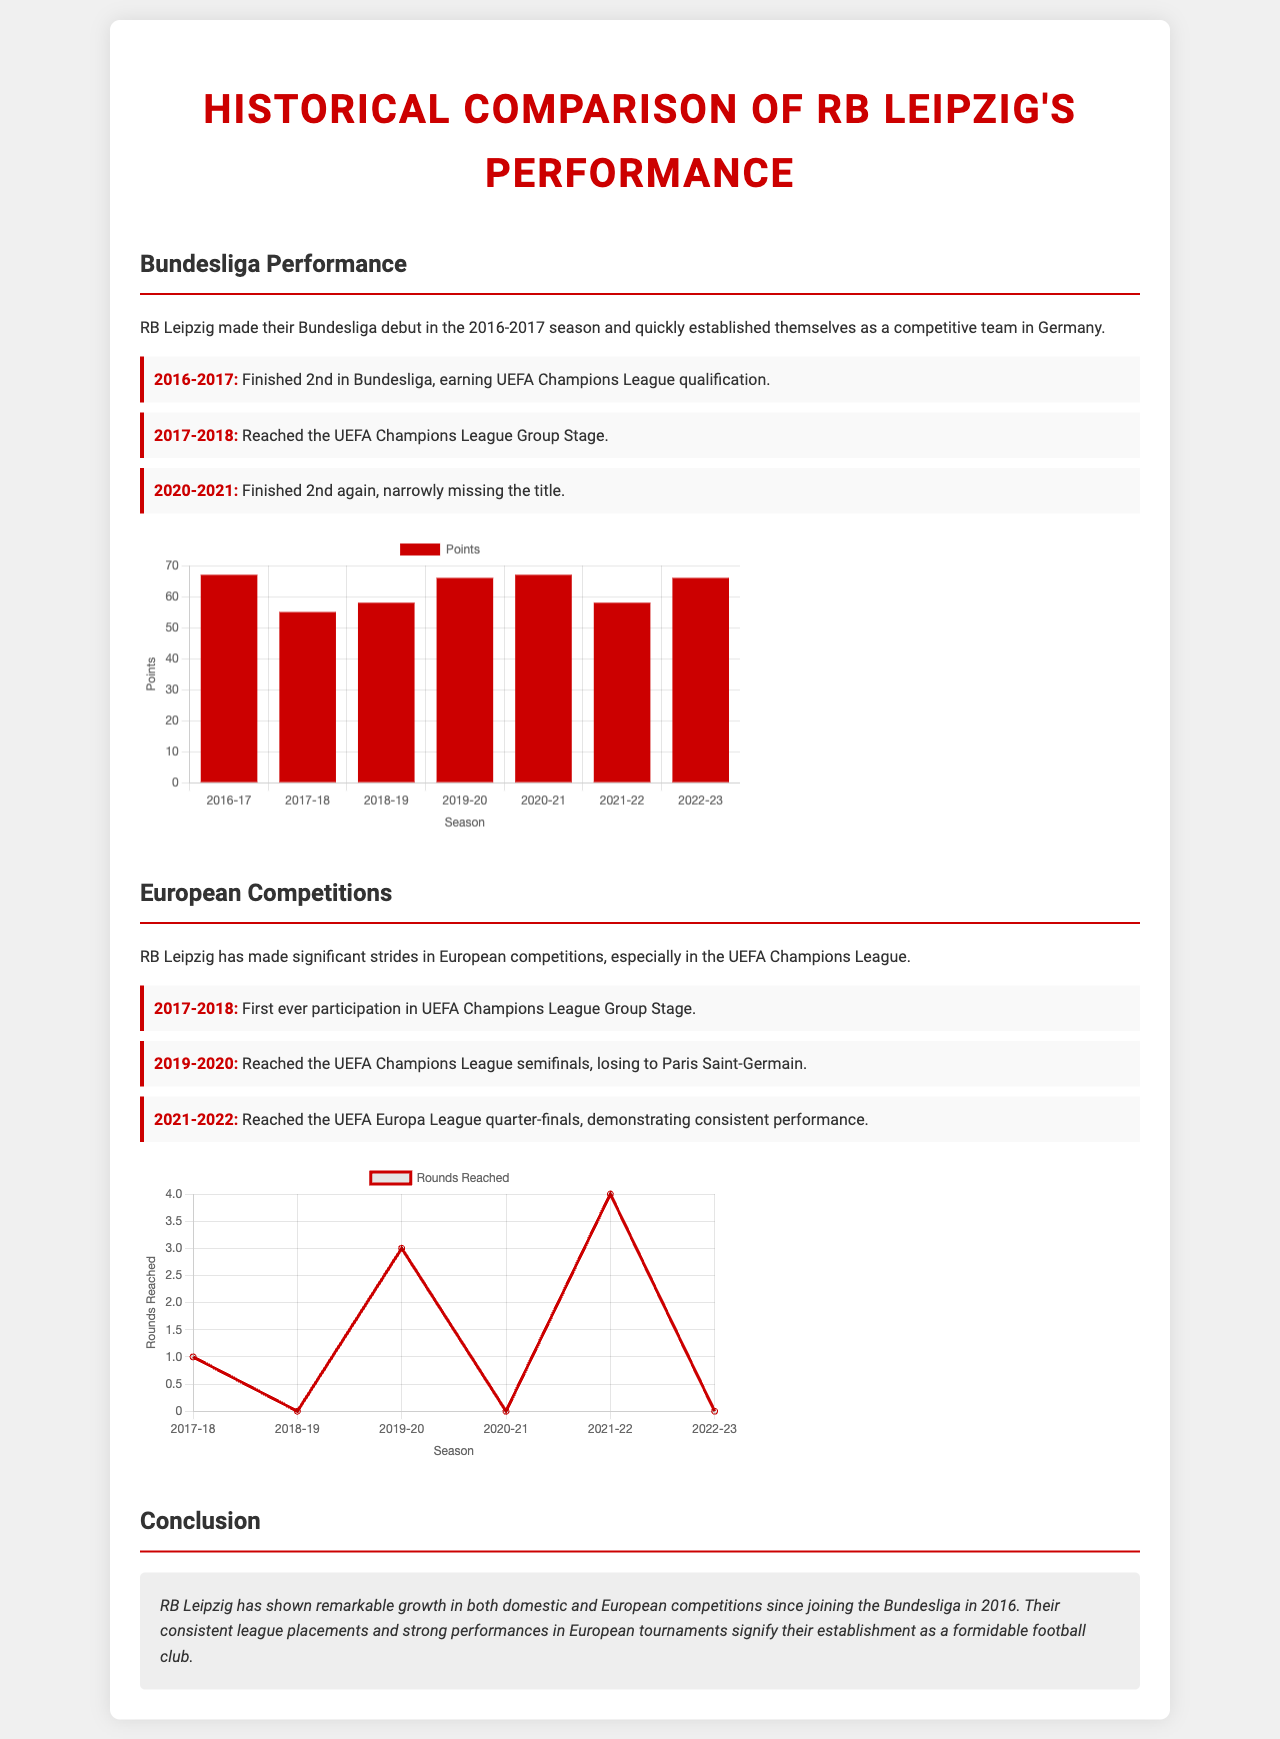What season did RB Leipzig make their Bundesliga debut? The document states that RB Leipzig made their Bundesliga debut in the 2016-2017 season.
Answer: 2016-2017 What was RB Leipzig's Bundesliga finish in 2020-2021? According to the milestones listed, RB Leipzig finished 2nd in Bundesliga in the 2020-2021 season.
Answer: 2nd In which year did RB Leipzig reach the UEFA Champions League semifinals? The milestone information indicates that RB Leipzig reached the UEFA Champions League semifinals in the 2019-2020 season.
Answer: 2019-2020 How many points did RB Leipzig earn in the 2016-2017 Bundesliga season? The Bundesliga chart shows that RB Leipzig earned 67 points in the 2016-2017 season.
Answer: 67 What is the highest number of rounds reached by RB Leipzig in European competitions according to the data? The European competitions chart reveals that the highest number of rounds reached was 4 in the 2021-2022 season.
Answer: 4 What color represents RB Leipzig's data in the Bundesliga chart? The document specifies that the color representing RB Leipzig's data in the Bundesliga chart is red.
Answer: Red How many seasons are depicted in the Bundesliga performance chart? The Bundesliga performance chart depicts performances over seven seasons from 2016-2023.
Answer: 7 Which milestone indicates RB Leipzig's first participation in European competition? The information shows the first participation in the UEFA Champions League Group Stage was in 2017-2018.
Answer: 2017-2018 